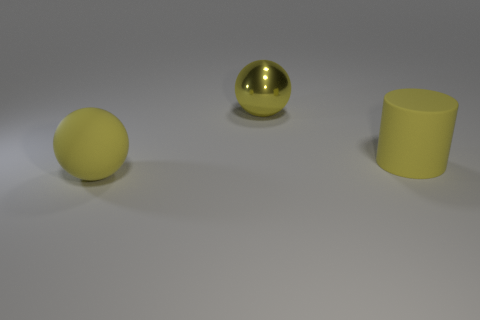Subtract 2 balls. How many balls are left? 0 Subtract all spheres. How many objects are left? 1 Subtract 0 purple cylinders. How many objects are left? 3 Subtract all blue cylinders. Subtract all purple spheres. How many cylinders are left? 1 Subtract all yellow cylinders. How many purple balls are left? 0 Subtract all large things. Subtract all tiny blue cubes. How many objects are left? 0 Add 1 large metallic objects. How many large metallic objects are left? 2 Add 3 big rubber spheres. How many big rubber spheres exist? 4 Add 1 big rubber objects. How many objects exist? 4 